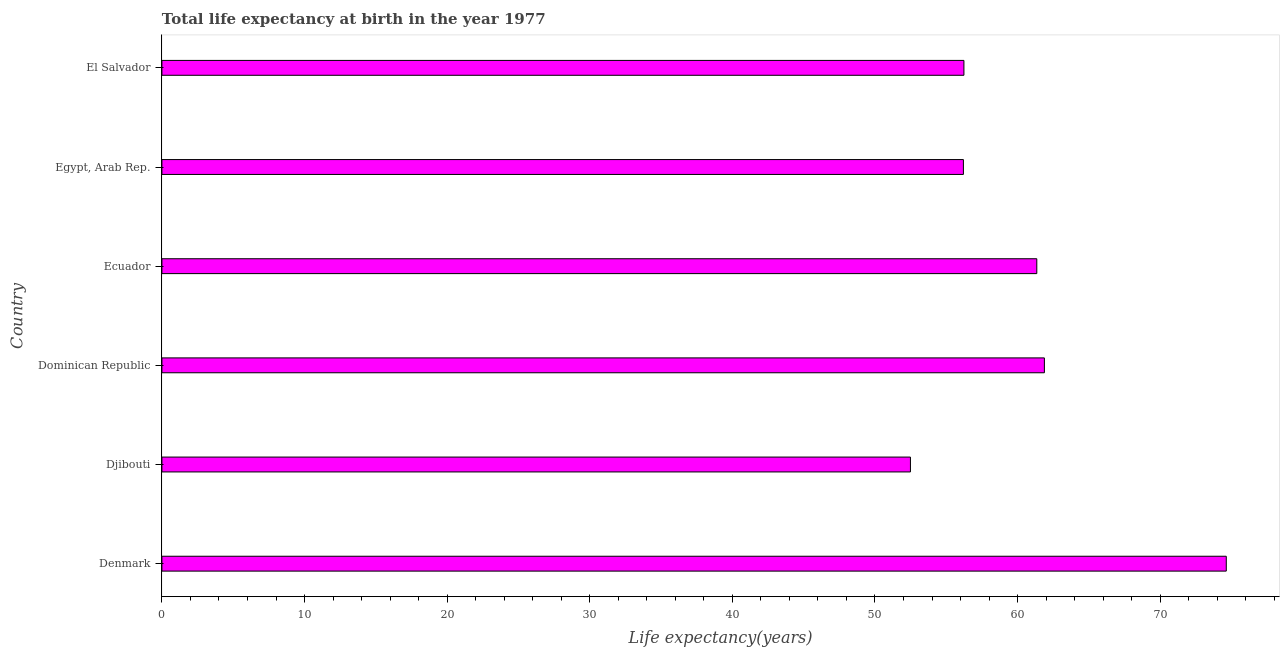Does the graph contain grids?
Ensure brevity in your answer.  No. What is the title of the graph?
Offer a very short reply. Total life expectancy at birth in the year 1977. What is the label or title of the X-axis?
Offer a very short reply. Life expectancy(years). What is the life expectancy at birth in El Salvador?
Your response must be concise. 56.24. Across all countries, what is the maximum life expectancy at birth?
Provide a short and direct response. 74.63. Across all countries, what is the minimum life expectancy at birth?
Offer a very short reply. 52.49. In which country was the life expectancy at birth maximum?
Offer a very short reply. Denmark. In which country was the life expectancy at birth minimum?
Provide a short and direct response. Djibouti. What is the sum of the life expectancy at birth?
Offer a very short reply. 362.78. What is the difference between the life expectancy at birth in Denmark and Dominican Republic?
Give a very brief answer. 12.75. What is the average life expectancy at birth per country?
Your answer should be very brief. 60.46. What is the median life expectancy at birth?
Make the answer very short. 58.79. What is the ratio of the life expectancy at birth in Djibouti to that in Egypt, Arab Rep.?
Your response must be concise. 0.93. Is the difference between the life expectancy at birth in Ecuador and Egypt, Arab Rep. greater than the difference between any two countries?
Your answer should be very brief. No. What is the difference between the highest and the second highest life expectancy at birth?
Your answer should be very brief. 12.75. Is the sum of the life expectancy at birth in Dominican Republic and Ecuador greater than the maximum life expectancy at birth across all countries?
Offer a terse response. Yes. What is the difference between the highest and the lowest life expectancy at birth?
Your answer should be very brief. 22.15. In how many countries, is the life expectancy at birth greater than the average life expectancy at birth taken over all countries?
Give a very brief answer. 3. What is the difference between two consecutive major ticks on the X-axis?
Ensure brevity in your answer.  10. Are the values on the major ticks of X-axis written in scientific E-notation?
Keep it short and to the point. No. What is the Life expectancy(years) in Denmark?
Give a very brief answer. 74.63. What is the Life expectancy(years) of Djibouti?
Offer a terse response. 52.49. What is the Life expectancy(years) in Dominican Republic?
Provide a succinct answer. 61.88. What is the Life expectancy(years) in Ecuador?
Make the answer very short. 61.35. What is the Life expectancy(years) in Egypt, Arab Rep.?
Offer a terse response. 56.2. What is the Life expectancy(years) in El Salvador?
Offer a terse response. 56.24. What is the difference between the Life expectancy(years) in Denmark and Djibouti?
Your answer should be compact. 22.15. What is the difference between the Life expectancy(years) in Denmark and Dominican Republic?
Offer a very short reply. 12.75. What is the difference between the Life expectancy(years) in Denmark and Ecuador?
Your response must be concise. 13.29. What is the difference between the Life expectancy(years) in Denmark and Egypt, Arab Rep.?
Offer a very short reply. 18.43. What is the difference between the Life expectancy(years) in Denmark and El Salvador?
Provide a succinct answer. 18.4. What is the difference between the Life expectancy(years) in Djibouti and Dominican Republic?
Offer a very short reply. -9.39. What is the difference between the Life expectancy(years) in Djibouti and Ecuador?
Give a very brief answer. -8.86. What is the difference between the Life expectancy(years) in Djibouti and Egypt, Arab Rep.?
Make the answer very short. -3.71. What is the difference between the Life expectancy(years) in Djibouti and El Salvador?
Make the answer very short. -3.75. What is the difference between the Life expectancy(years) in Dominican Republic and Ecuador?
Ensure brevity in your answer.  0.53. What is the difference between the Life expectancy(years) in Dominican Republic and Egypt, Arab Rep.?
Make the answer very short. 5.68. What is the difference between the Life expectancy(years) in Dominican Republic and El Salvador?
Offer a very short reply. 5.64. What is the difference between the Life expectancy(years) in Ecuador and Egypt, Arab Rep.?
Keep it short and to the point. 5.15. What is the difference between the Life expectancy(years) in Ecuador and El Salvador?
Give a very brief answer. 5.11. What is the difference between the Life expectancy(years) in Egypt, Arab Rep. and El Salvador?
Provide a short and direct response. -0.04. What is the ratio of the Life expectancy(years) in Denmark to that in Djibouti?
Offer a terse response. 1.42. What is the ratio of the Life expectancy(years) in Denmark to that in Dominican Republic?
Provide a short and direct response. 1.21. What is the ratio of the Life expectancy(years) in Denmark to that in Ecuador?
Ensure brevity in your answer.  1.22. What is the ratio of the Life expectancy(years) in Denmark to that in Egypt, Arab Rep.?
Offer a very short reply. 1.33. What is the ratio of the Life expectancy(years) in Denmark to that in El Salvador?
Ensure brevity in your answer.  1.33. What is the ratio of the Life expectancy(years) in Djibouti to that in Dominican Republic?
Provide a short and direct response. 0.85. What is the ratio of the Life expectancy(years) in Djibouti to that in Ecuador?
Offer a very short reply. 0.86. What is the ratio of the Life expectancy(years) in Djibouti to that in Egypt, Arab Rep.?
Offer a very short reply. 0.93. What is the ratio of the Life expectancy(years) in Djibouti to that in El Salvador?
Ensure brevity in your answer.  0.93. What is the ratio of the Life expectancy(years) in Dominican Republic to that in Egypt, Arab Rep.?
Your response must be concise. 1.1. What is the ratio of the Life expectancy(years) in Ecuador to that in Egypt, Arab Rep.?
Provide a succinct answer. 1.09. What is the ratio of the Life expectancy(years) in Ecuador to that in El Salvador?
Provide a short and direct response. 1.09. What is the ratio of the Life expectancy(years) in Egypt, Arab Rep. to that in El Salvador?
Provide a short and direct response. 1. 